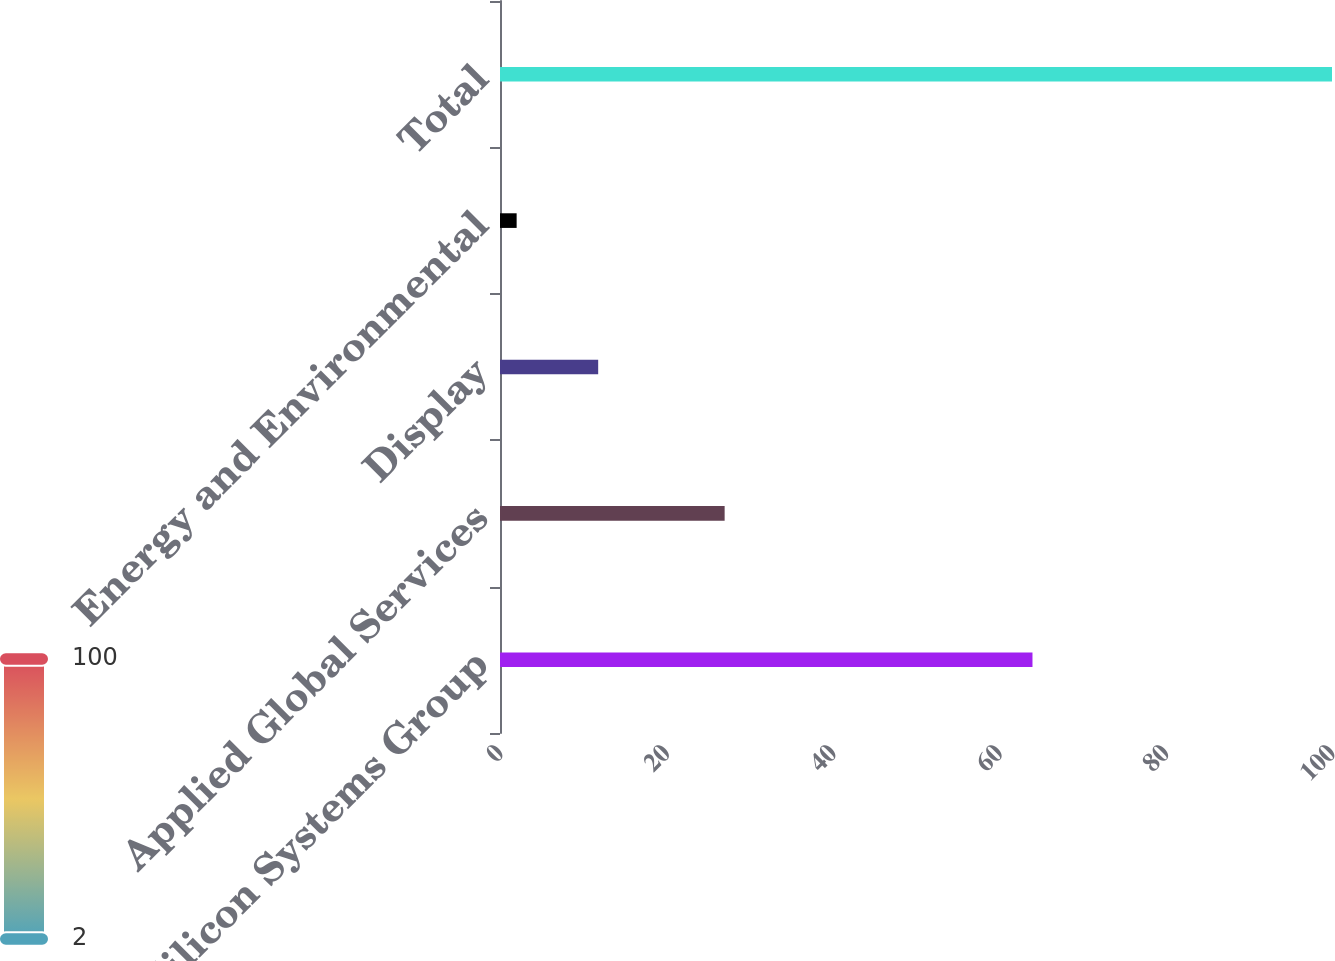Convert chart to OTSL. <chart><loc_0><loc_0><loc_500><loc_500><bar_chart><fcel>Silicon Systems Group<fcel>Applied Global Services<fcel>Display<fcel>Energy and Environmental<fcel>Total<nl><fcel>64<fcel>27<fcel>11.8<fcel>2<fcel>100<nl></chart> 